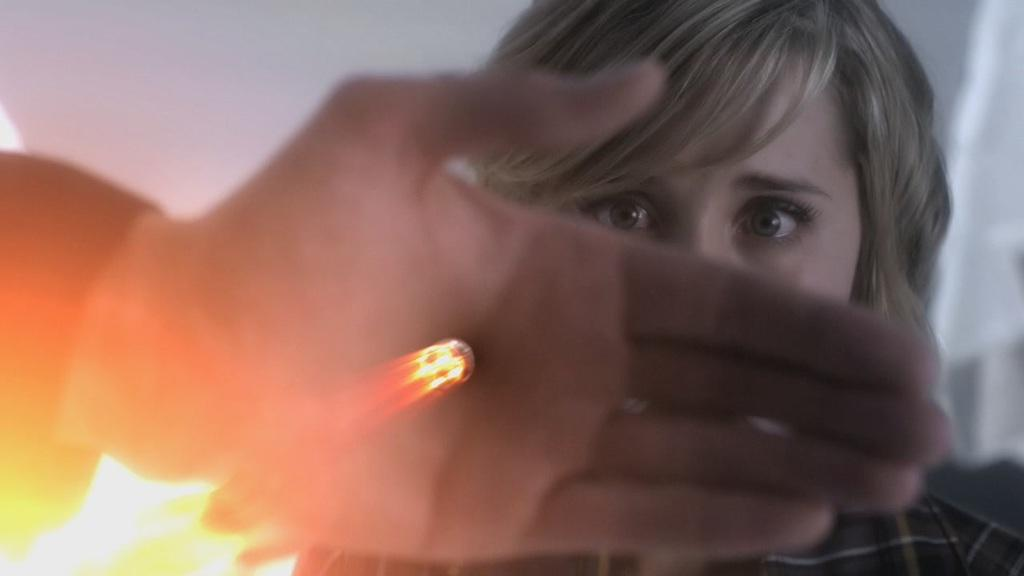What is the main subject of the image? There is a person in the image. Can you describe any specific body part of the person in the image? There is a hand of a person in the image. What is the condition of the background in the image? The background of the image is blurred. What type of voice can be heard coming from the person's daughter in the image? There is no reference to a daughter or any sounds in the image, so it's not possible to determine what, if any, voice might be heard. 